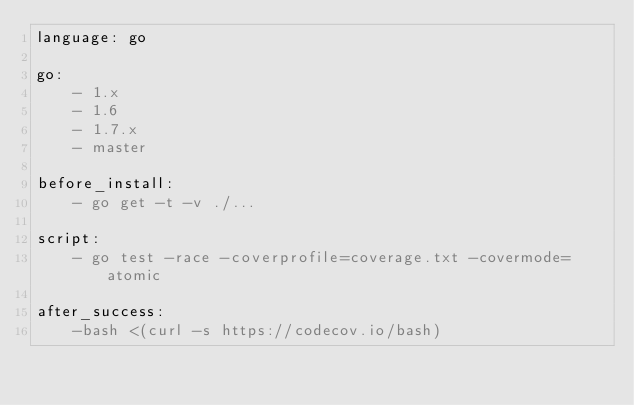Convert code to text. <code><loc_0><loc_0><loc_500><loc_500><_YAML_>language: go

go:
    - 1.x
    - 1.6
    - 1.7.x
    - master

before_install:
    - go get -t -v ./...

script:
    - go test -race -coverprofile=coverage.txt -covermode=atomic

after_success:
    -bash <(curl -s https://codecov.io/bash)
</code> 